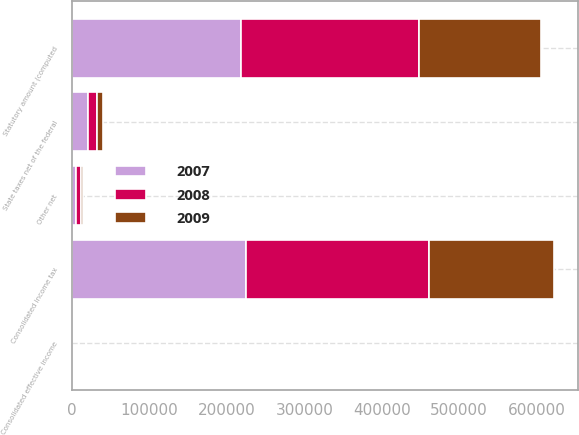Convert chart. <chart><loc_0><loc_0><loc_500><loc_500><stacked_bar_chart><ecel><fcel>Statutory amount (computed<fcel>State taxes net of the federal<fcel>Other net<fcel>Consolidated income tax<fcel>Consolidated effective income<nl><fcel>2007<fcel>218671<fcel>19848<fcel>5071<fcel>224919<fcel>36<nl><fcel>2008<fcel>230094<fcel>12317<fcel>5742<fcel>236669<fcel>36<nl><fcel>2009<fcel>157025<fcel>7397<fcel>2910<fcel>161512<fcel>36<nl></chart> 